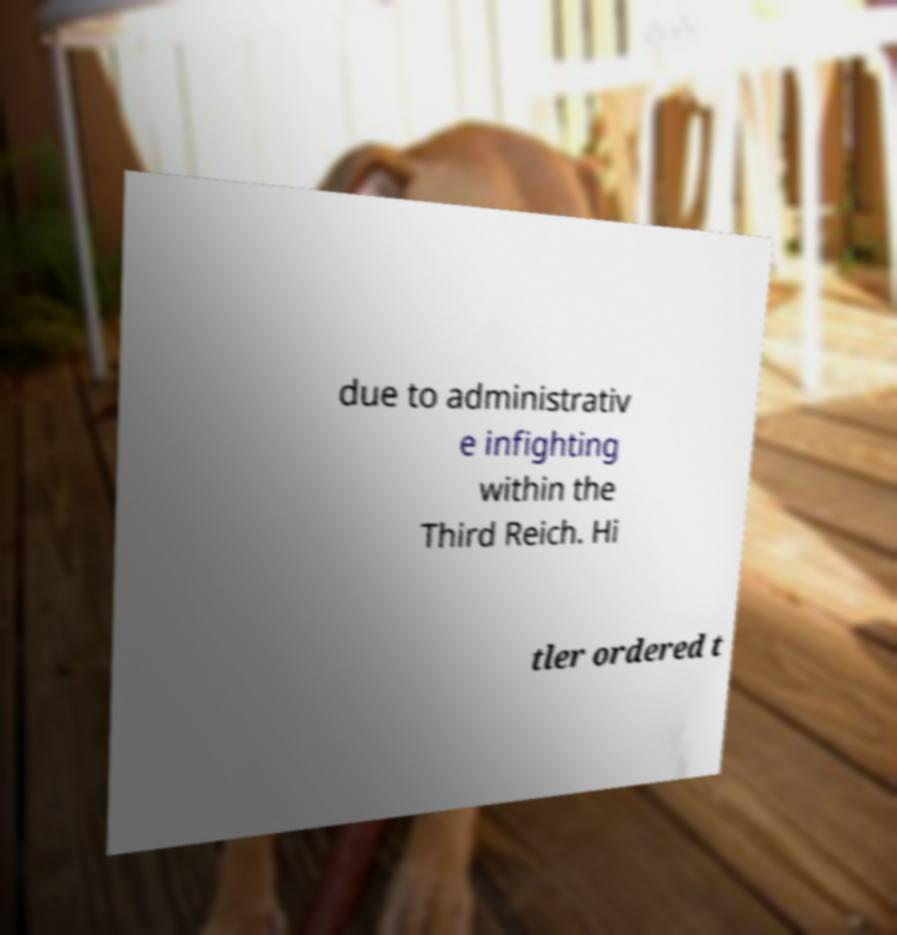Could you assist in decoding the text presented in this image and type it out clearly? due to administrativ e infighting within the Third Reich. Hi tler ordered t 